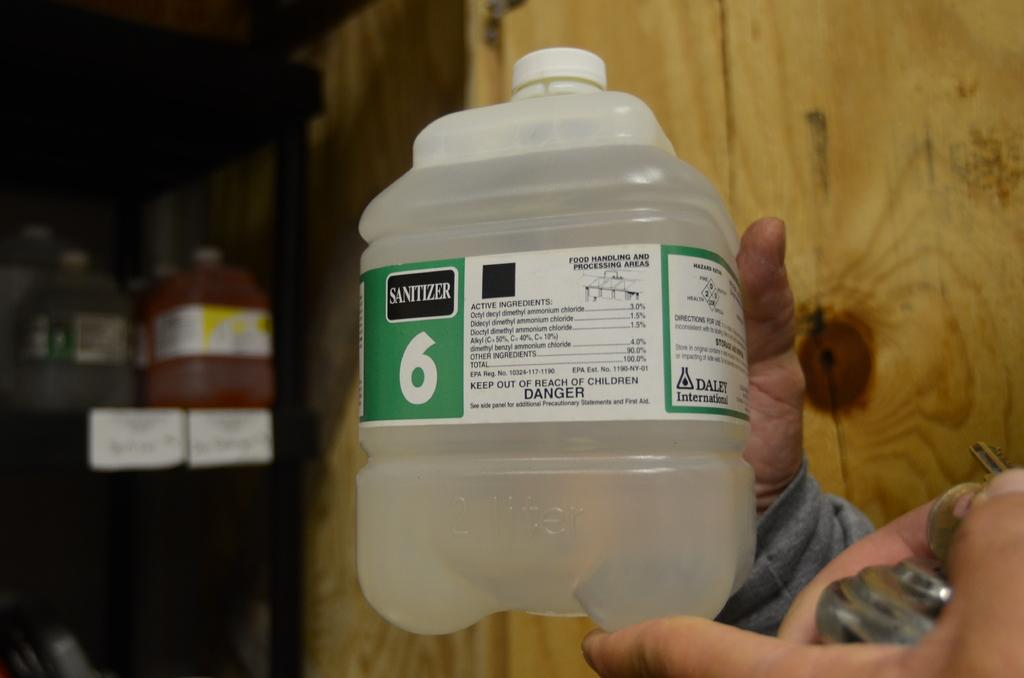What is the main subject of the image? The main subject of the image is a man. What is the man holding in the image? The man is holding a bottle of sanitizer. How many girls are present in the image? There is no girl present in the image; it only features a man holding a bottle of sanitizer. What type of noise can be heard coming from the man in the image? There is no indication of any noise in the image, as it only shows a man holding a bottle of sanitizer. 